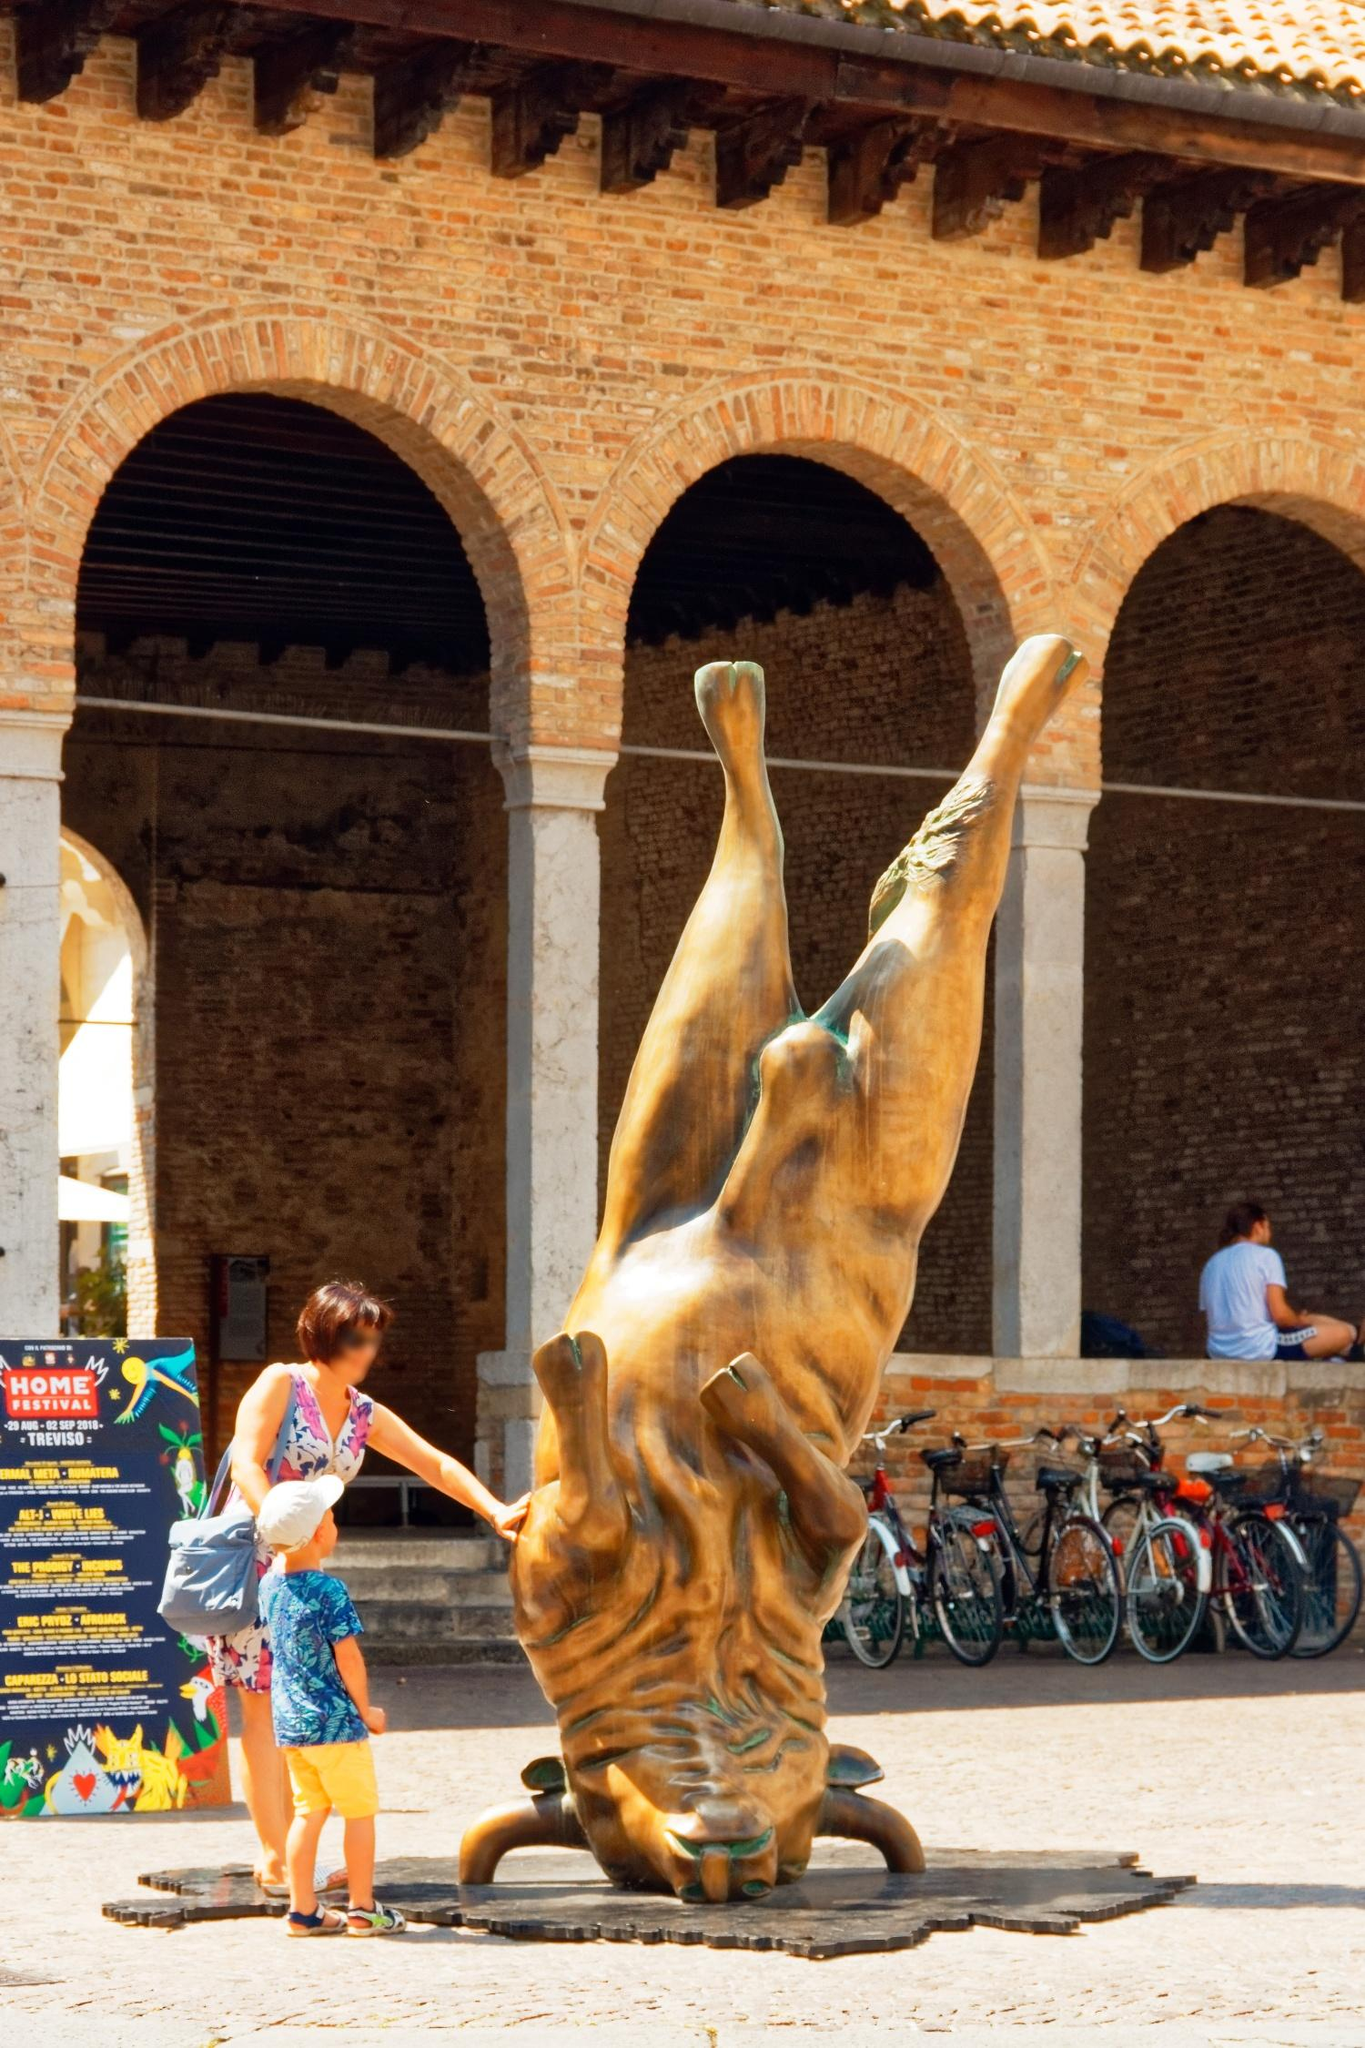Describe the context and atmosphere around the bronze bull sculpture. The bronze bull sculpture is located in a lively and historically rich courtyard of the Castello Sforzesco in Milan. The setting is a blend of antiquity and modern life, encapsulated by the brick arches that surround the space. The arches bear the mark of historical architecture, creating an aura of timelessness around the courtyard.

There's a sense of everyday normalcy interwoven with cultural contemplation as people move about the space. Bicycles parked against the walls signify daily commuting, suggesting the castle's accessibility to residents and visitors alike. The presence of individuals interacting with the sculpture—ranging from a child’s inquisitive gaze to a woman’s tactile exploration—adds a dynamic, human element to the atmosphere.

The courtyard feels like a cultural crossroad where history meets contemporary life. The sign advertising a 'HOME Festival' in Treviso further enhances this atmosphere, suggesting that the courtyard is not just a static remnant of the past but a vibrant space for current artistic expression and events. 